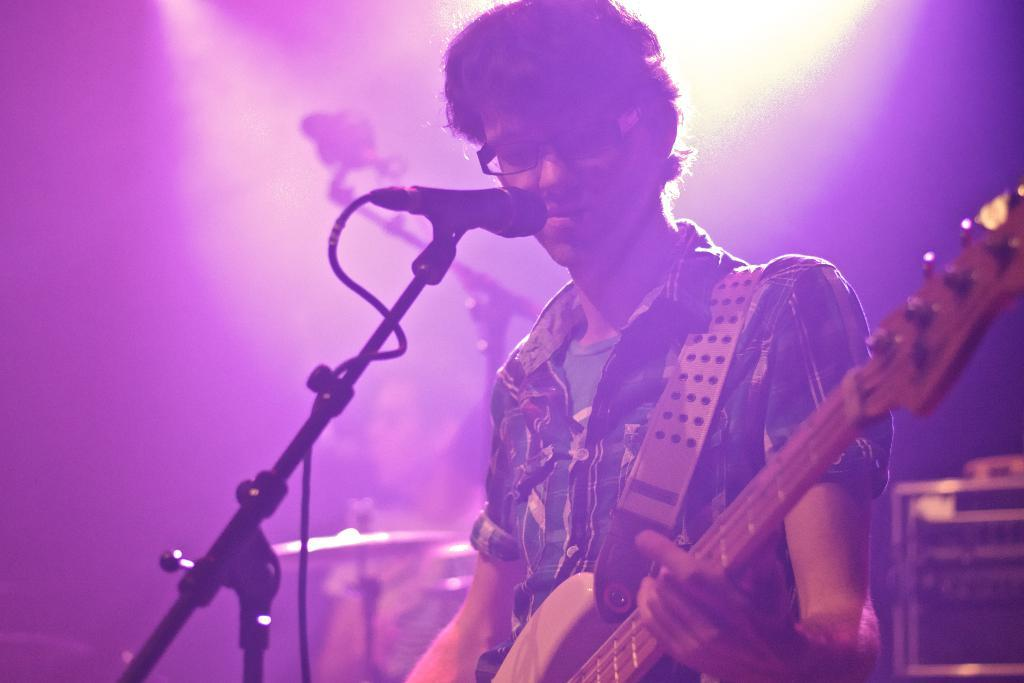What is the man in the image doing? The man is standing in the center of the image and holding a guitar. What object is in front of the man? There is a microphone in front of the man. What can be seen in the background of the image? There is a wall and musical instruments in the background of the image. What type of pets does the man have in the image? There are no pets visible in the image. What sense does the man use to play the guitar in the image? The man uses his sense of touch and hearing to play the guitar in the image, but the question is misleading as it implies that the image can convey information about the man's senses, which it cannot. 